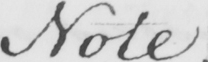Can you tell me what this handwritten text says? Note . 